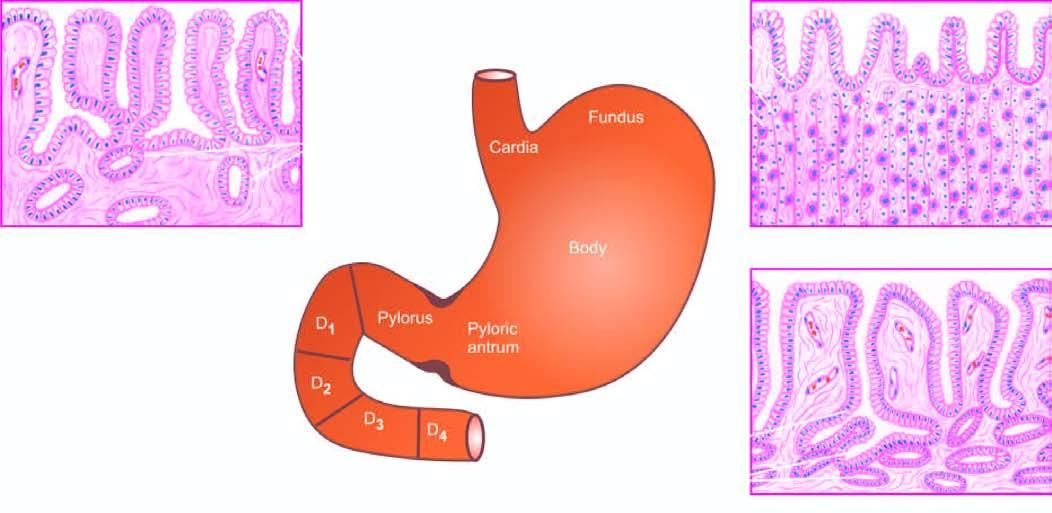what are natomical subdivisions of the stomach correlated with of gastric mucosa in different regions?
Answer the question using a single word or phrase. Anatomical histological appearance regions 